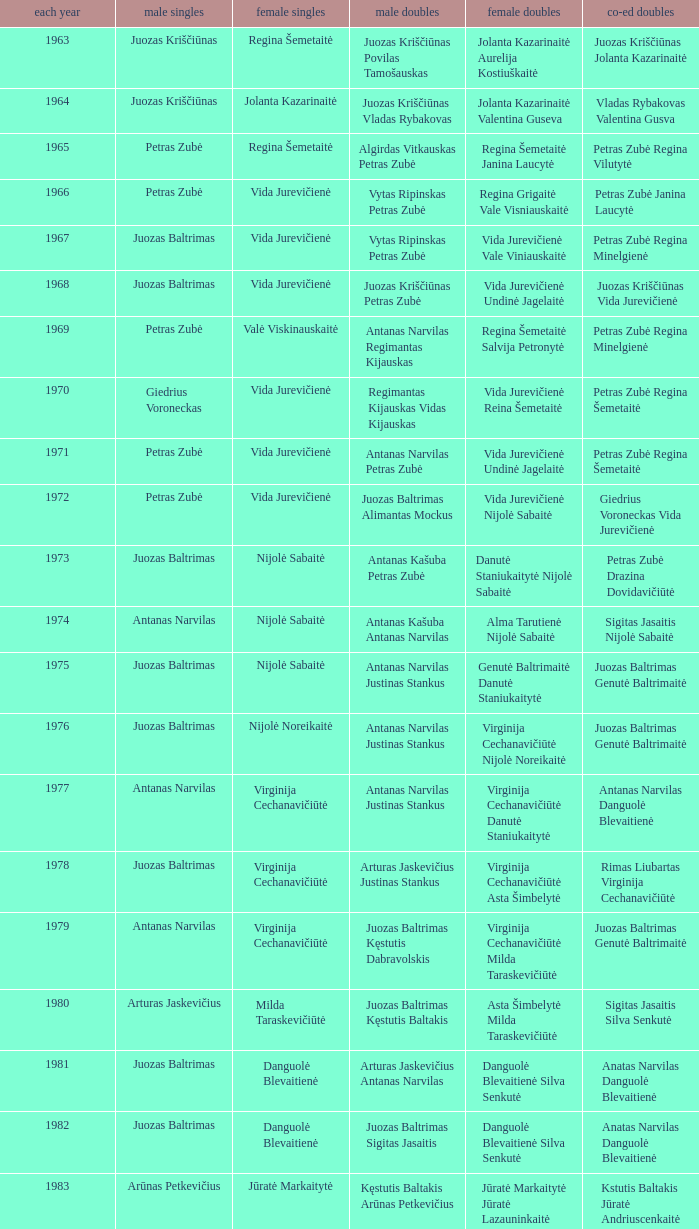What was the first year of the Lithuanian National Badminton Championships? 1963.0. 